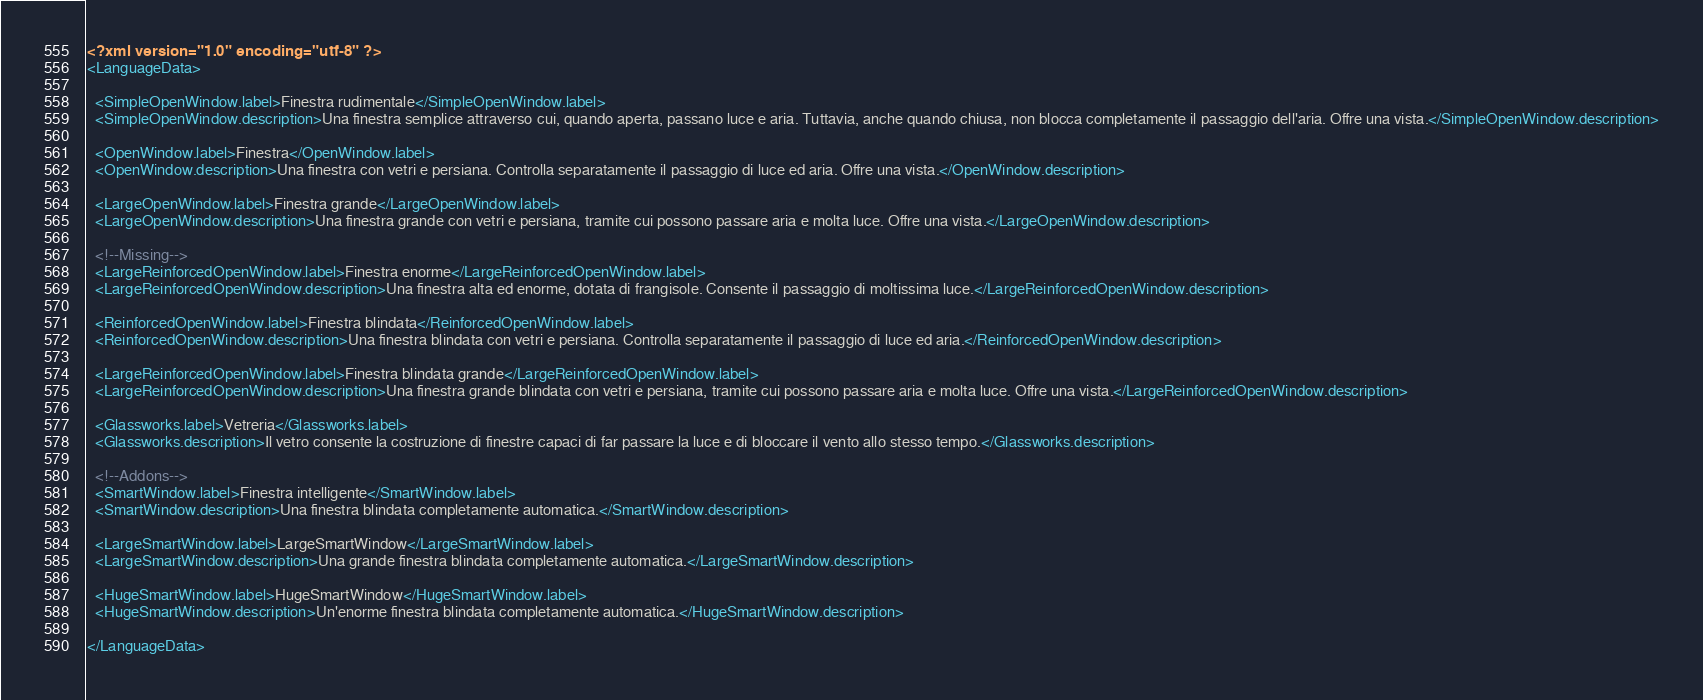Convert code to text. <code><loc_0><loc_0><loc_500><loc_500><_XML_><?xml version="1.0" encoding="utf-8" ?>
<LanguageData>

  <SimpleOpenWindow.label>Finestra rudimentale</SimpleOpenWindow.label>
  <SimpleOpenWindow.description>Una finestra semplice attraverso cui, quando aperta, passano luce e aria. Tuttavia, anche quando chiusa, non blocca completamente il passaggio dell'aria. Offre una vista.</SimpleOpenWindow.description>

  <OpenWindow.label>Finestra</OpenWindow.label>
  <OpenWindow.description>Una finestra con vetri e persiana. Controlla separatamente il passaggio di luce ed aria. Offre una vista.</OpenWindow.description>

  <LargeOpenWindow.label>Finestra grande</LargeOpenWindow.label>
  <LargeOpenWindow.description>Una finestra grande con vetri e persiana, tramite cui possono passare aria e molta luce. Offre una vista.</LargeOpenWindow.description>

  <!--Missing-->
  <LargeReinforcedOpenWindow.label>Finestra enorme</LargeReinforcedOpenWindow.label>
  <LargeReinforcedOpenWindow.description>Una finestra alta ed enorme, dotata di frangisole. Consente il passaggio di moltissima luce.</LargeReinforcedOpenWindow.description>

  <ReinforcedOpenWindow.label>Finestra blindata</ReinforcedOpenWindow.label>
  <ReinforcedOpenWindow.description>Una finestra blindata con vetri e persiana. Controlla separatamente il passaggio di luce ed aria.</ReinforcedOpenWindow.description>

  <LargeReinforcedOpenWindow.label>Finestra blindata grande</LargeReinforcedOpenWindow.label>
  <LargeReinforcedOpenWindow.description>Una finestra grande blindata con vetri e persiana, tramite cui possono passare aria e molta luce. Offre una vista.</LargeReinforcedOpenWindow.description>

  <Glassworks.label>Vetreria</Glassworks.label>
  <Glassworks.description>Il vetro consente la costruzione di finestre capaci di far passare la luce e di bloccare il vento allo stesso tempo.</Glassworks.description>

  <!--Addons-->
  <SmartWindow.label>Finestra intelligente</SmartWindow.label>
  <SmartWindow.description>Una finestra blindata completamente automatica.</SmartWindow.description>

  <LargeSmartWindow.label>LargeSmartWindow</LargeSmartWindow.label>
  <LargeSmartWindow.description>Una grande finestra blindata completamente automatica.</LargeSmartWindow.description>

  <HugeSmartWindow.label>HugeSmartWindow</HugeSmartWindow.label>
  <HugeSmartWindow.description>Un'enorme finestra blindata completamente automatica.</HugeSmartWindow.description>
  
</LanguageData>
</code> 